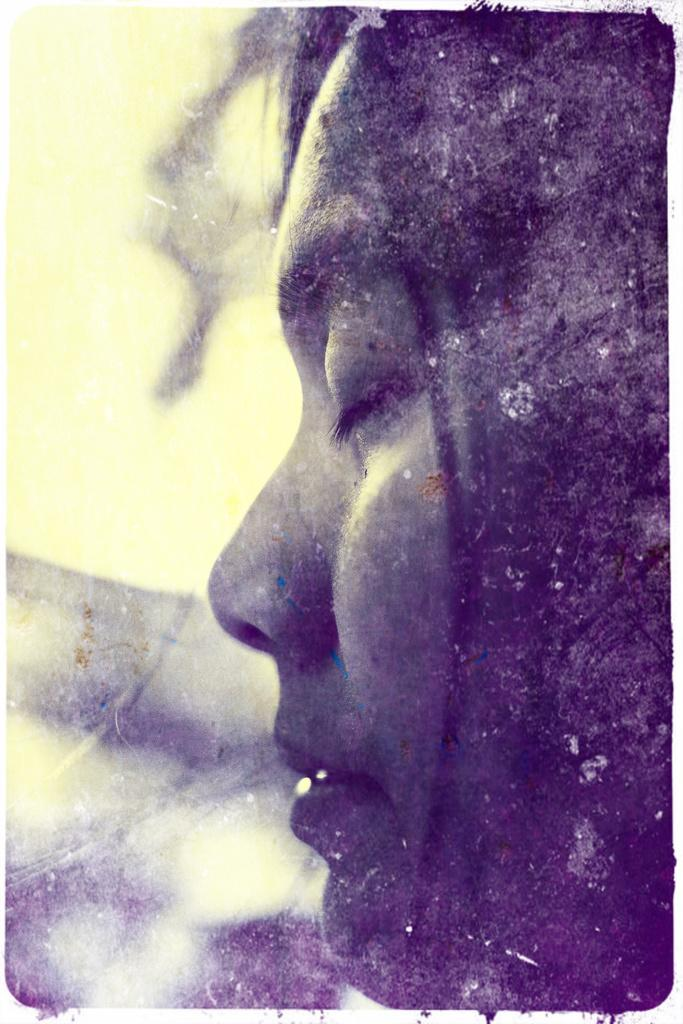What is the main subject of the picture? The main subject of the picture is a woman. What is the woman doing in the picture? The woman has her eyes closed and is smiling. What type of hydrant is visible in the background of the image? There is no hydrant present in the image. What is the rate of the woman's voyage in the image? There is no voyage depicted in the image, so there is no rate to determine. 